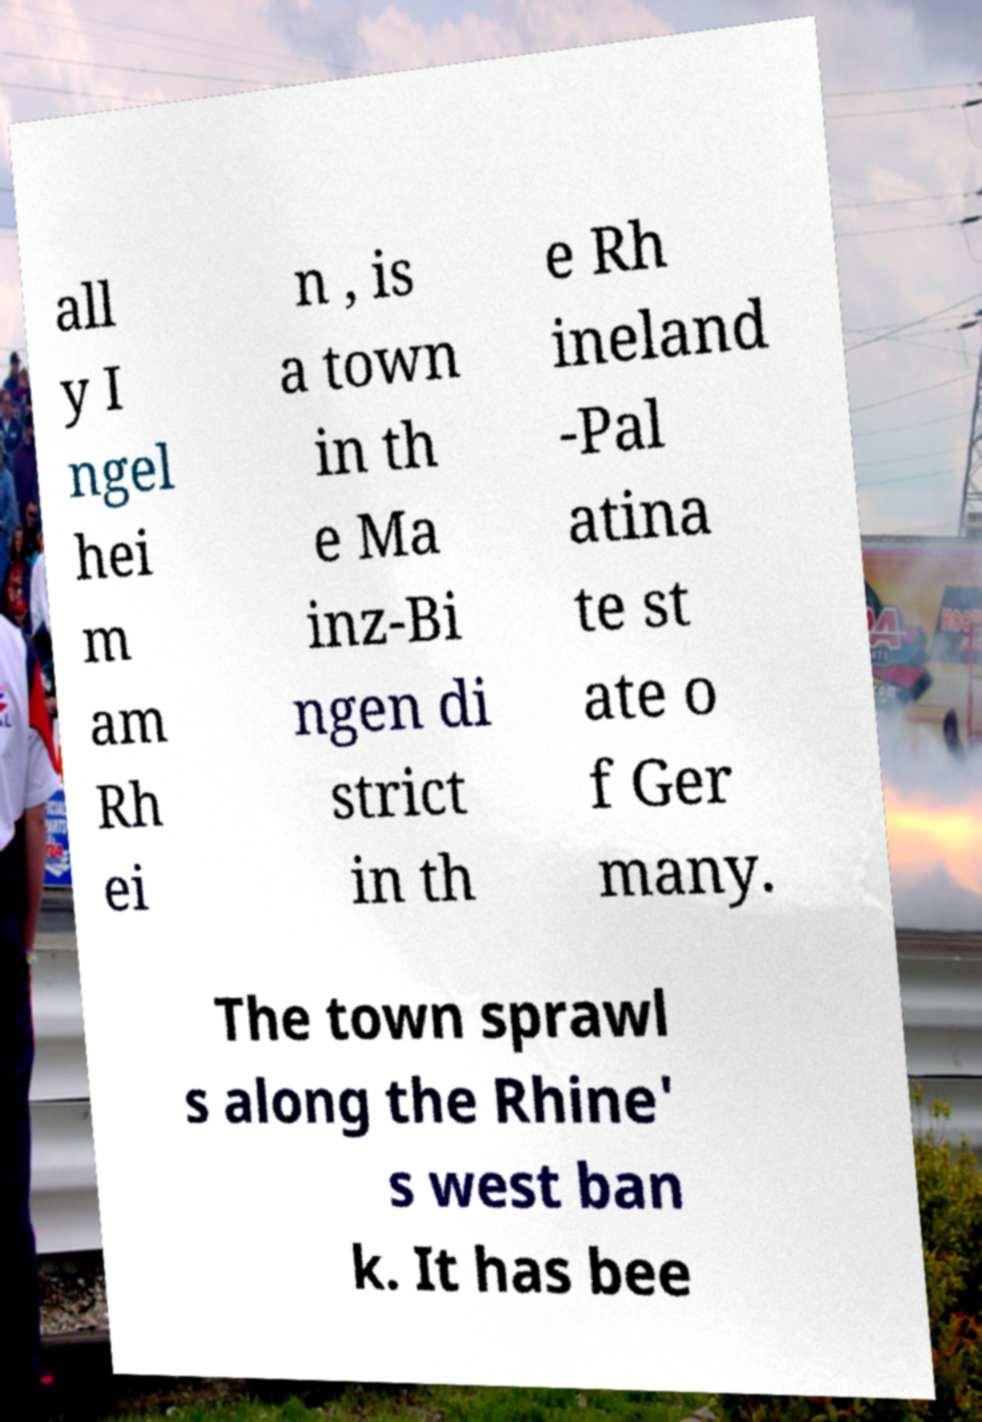I need the written content from this picture converted into text. Can you do that? all y I ngel hei m am Rh ei n , is a town in th e Ma inz-Bi ngen di strict in th e Rh ineland -Pal atina te st ate o f Ger many. The town sprawl s along the Rhine' s west ban k. It has bee 